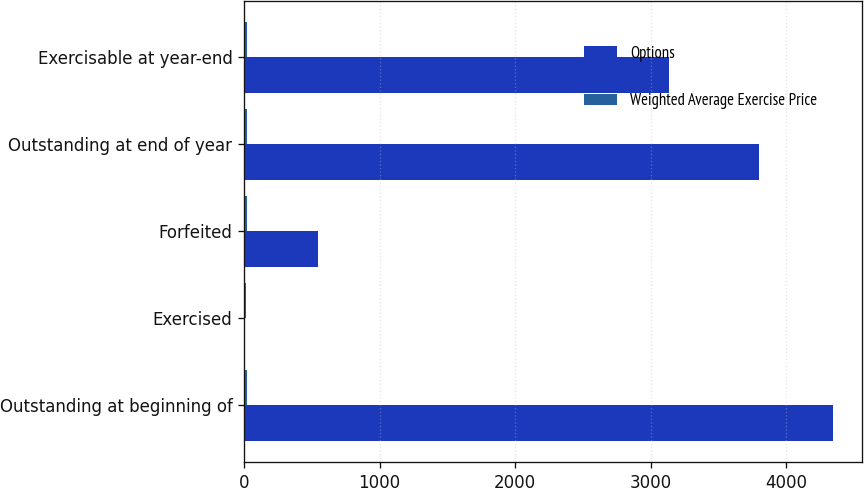<chart> <loc_0><loc_0><loc_500><loc_500><stacked_bar_chart><ecel><fcel>Outstanding at beginning of<fcel>Exercised<fcel>Forfeited<fcel>Outstanding at end of year<fcel>Exercisable at year-end<nl><fcel>Options<fcel>4347<fcel>2<fcel>542<fcel>3803<fcel>3133<nl><fcel>Weighted Average Exercise Price<fcel>18.92<fcel>10.42<fcel>22.24<fcel>18.45<fcel>19.08<nl></chart> 